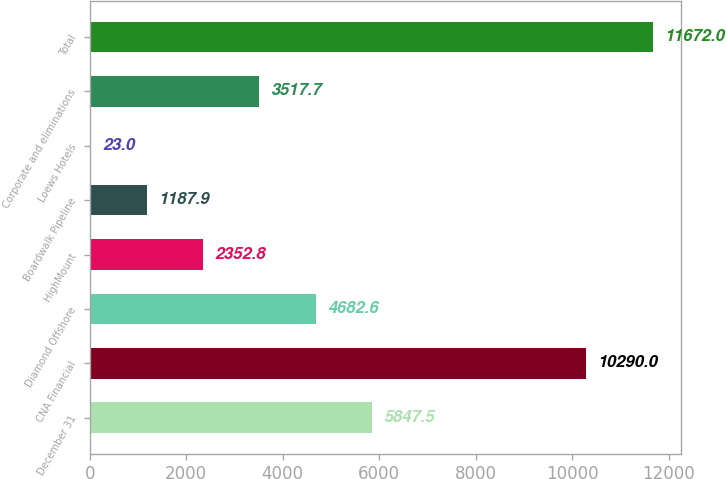<chart> <loc_0><loc_0><loc_500><loc_500><bar_chart><fcel>December 31<fcel>CNA Financial<fcel>Diamond Offshore<fcel>HighMount<fcel>Boardwalk Pipeline<fcel>Loews Hotels<fcel>Corporate and eliminations<fcel>Total<nl><fcel>5847.5<fcel>10290<fcel>4682.6<fcel>2352.8<fcel>1187.9<fcel>23<fcel>3517.7<fcel>11672<nl></chart> 